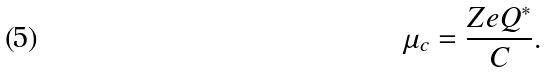<formula> <loc_0><loc_0><loc_500><loc_500>\mu _ { c } = \frac { Z e Q ^ { \ast } } { C } .</formula> 